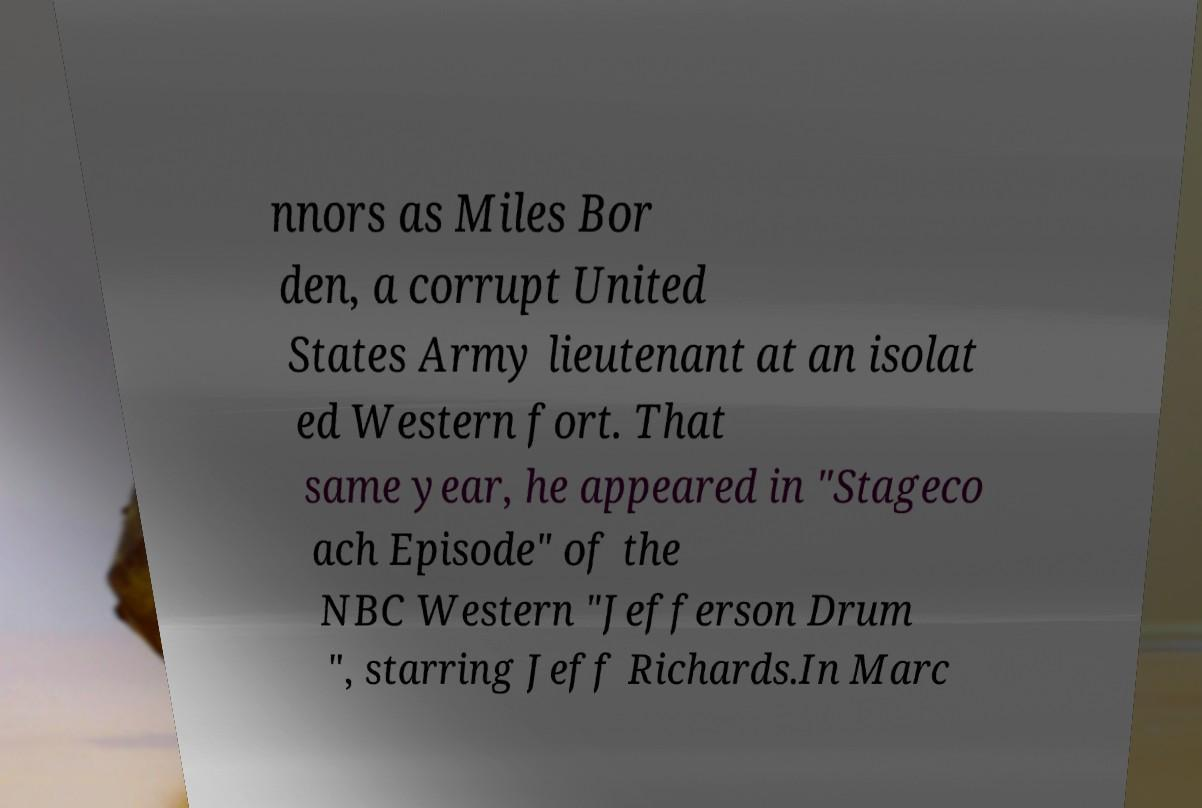Can you accurately transcribe the text from the provided image for me? nnors as Miles Bor den, a corrupt United States Army lieutenant at an isolat ed Western fort. That same year, he appeared in "Stageco ach Episode" of the NBC Western "Jefferson Drum ", starring Jeff Richards.In Marc 